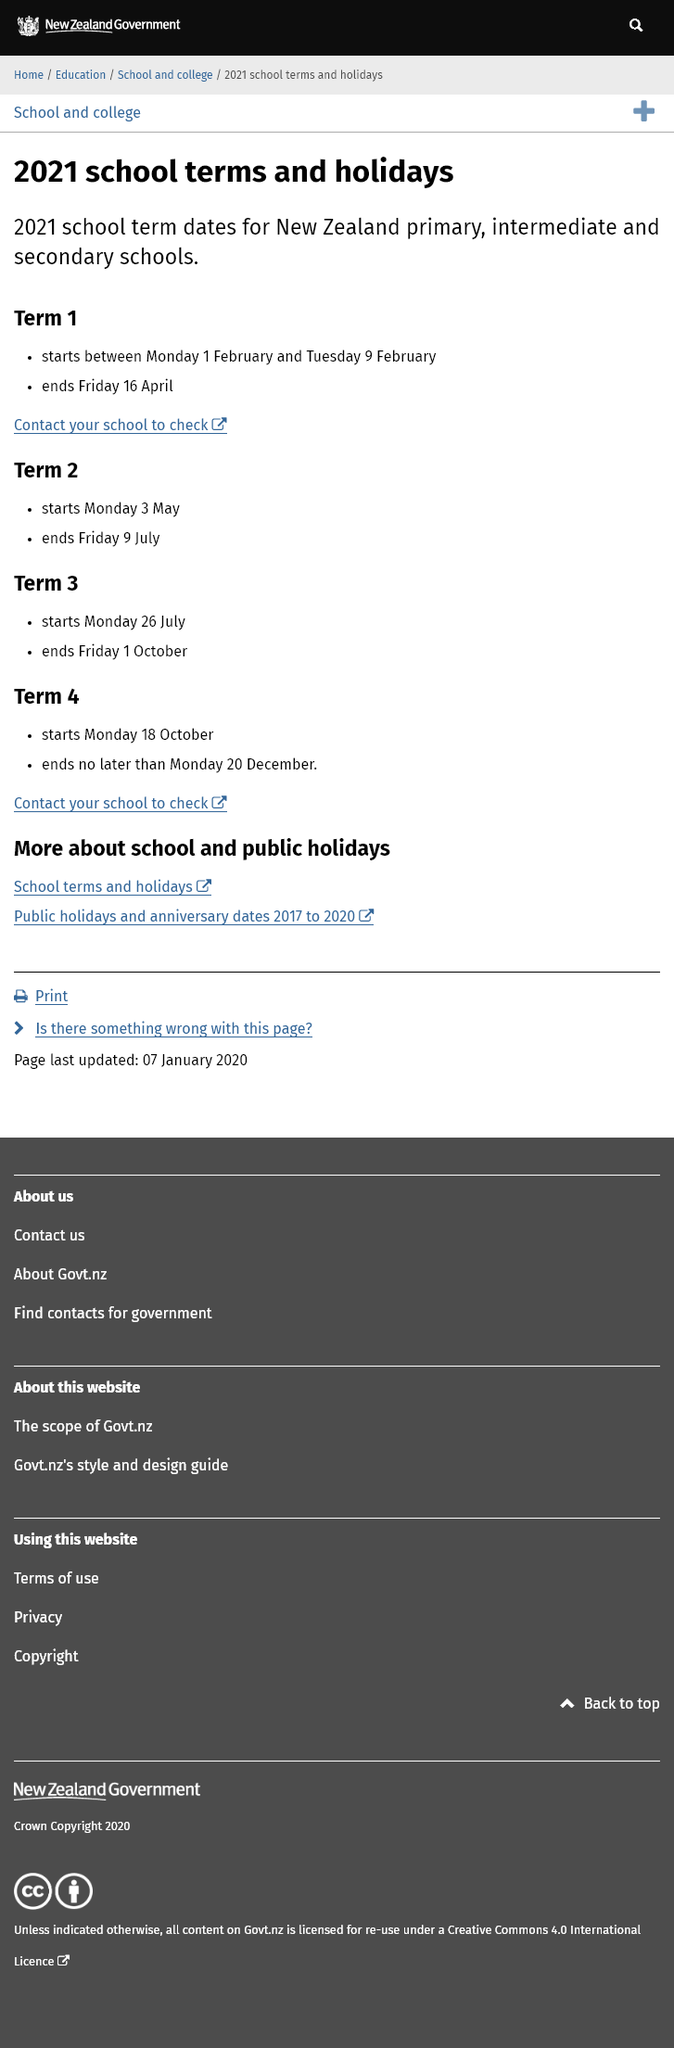Identify some key points in this picture. Term 3 ends on Friday, October 1st. It is possible to determine the start of term 1 by reaching out to the school for confirmation. Term 4 will commence on Monday, 18th October. 